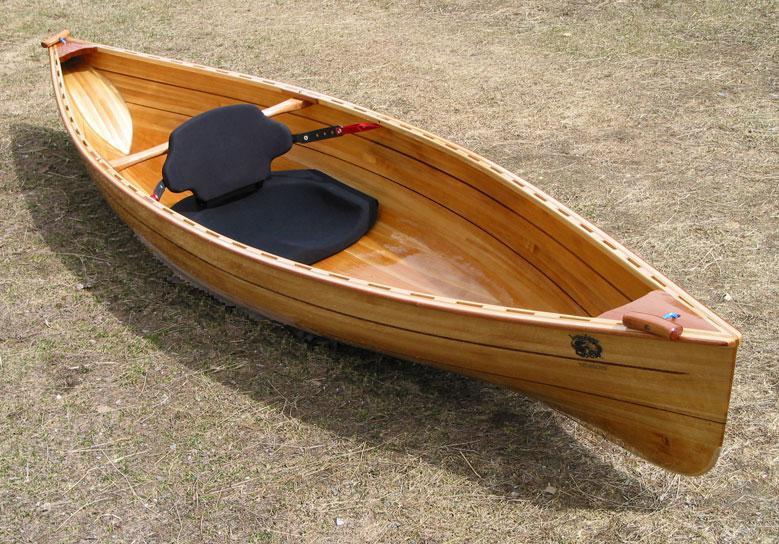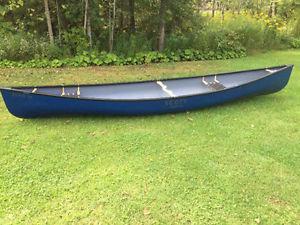The first image is the image on the left, the second image is the image on the right. Considering the images on both sides, is "An image shows one canoe pulled up to the edge of a body of water." valid? Answer yes or no. No. The first image is the image on the left, the second image is the image on the right. Given the left and right images, does the statement "In one image a single wooden canoe is angled to show the fine wood grain of its interior, while a second image shows one or more painted canoes on grass." hold true? Answer yes or no. Yes. 